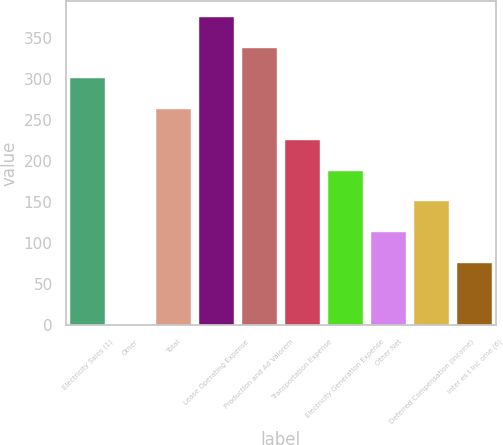Convert chart. <chart><loc_0><loc_0><loc_500><loc_500><bar_chart><fcel>Electricity Sales (1)<fcel>Other<fcel>Total<fcel>Lease Operating Expense<fcel>Production and Ad Valorem<fcel>Transportation Expense<fcel>Electricity Generation Expense<fcel>Other Net<fcel>Deferred Compensation (Income)<fcel>Inter es t Inc ome (6)<nl><fcel>301<fcel>1<fcel>263.5<fcel>376<fcel>338.5<fcel>226<fcel>188.5<fcel>113.5<fcel>151<fcel>76<nl></chart> 